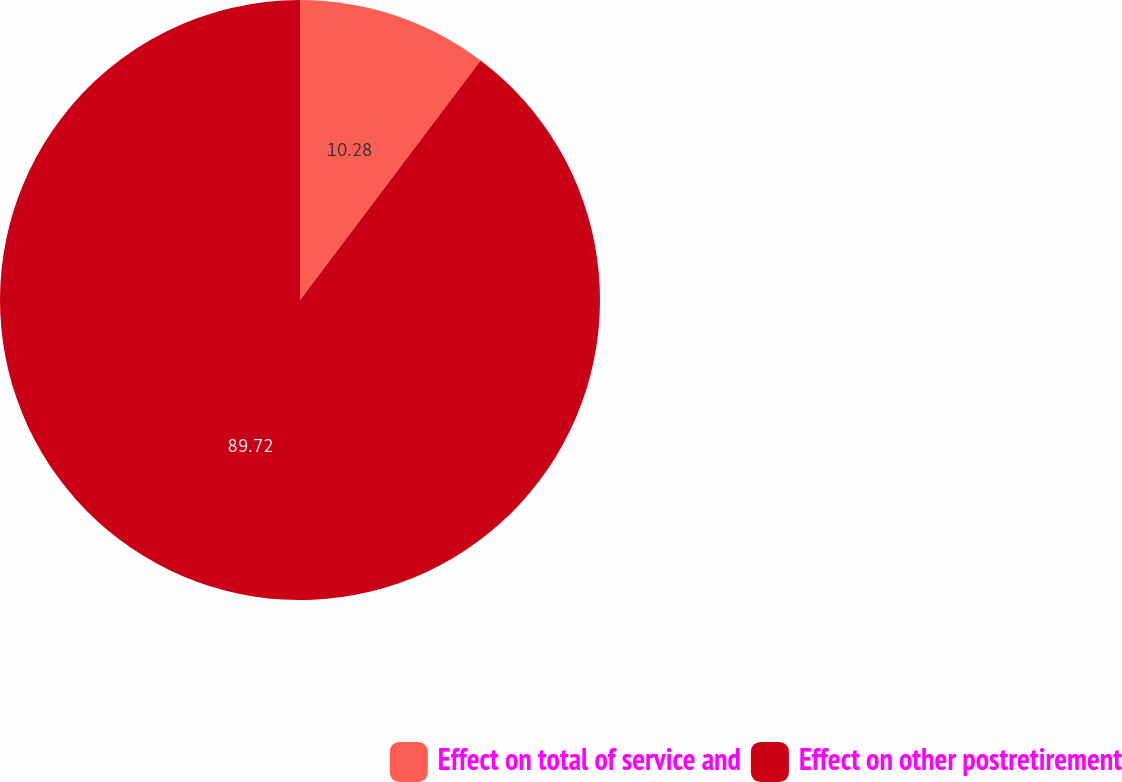Convert chart to OTSL. <chart><loc_0><loc_0><loc_500><loc_500><pie_chart><fcel>Effect on total of service and<fcel>Effect on other postretirement<nl><fcel>10.28%<fcel>89.72%<nl></chart> 